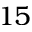<formula> <loc_0><loc_0><loc_500><loc_500>1 5</formula> 